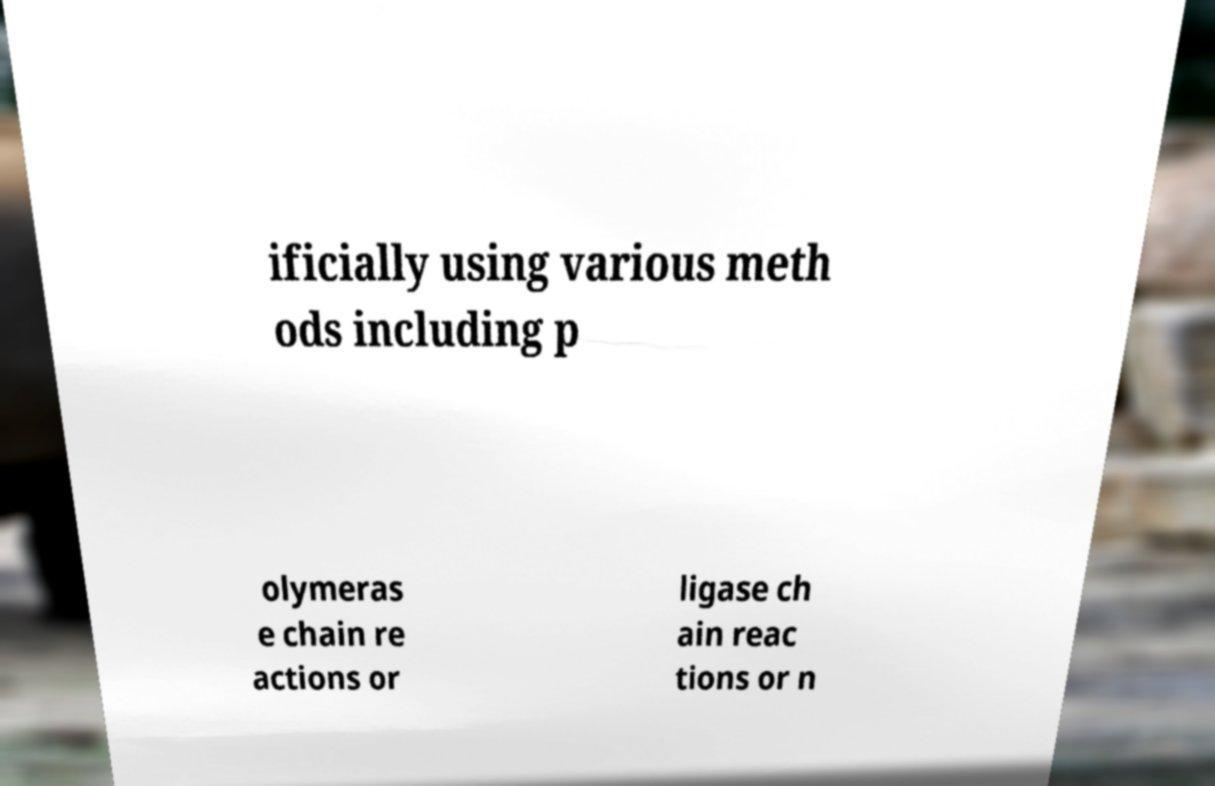Please identify and transcribe the text found in this image. ificially using various meth ods including p olymeras e chain re actions or ligase ch ain reac tions or n 